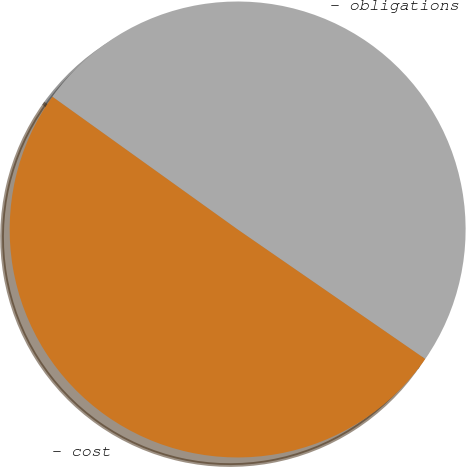Convert chart. <chart><loc_0><loc_0><loc_500><loc_500><pie_chart><fcel>- obligations<fcel>- cost<nl><fcel>49.72%<fcel>50.28%<nl></chart> 